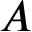Convert formula to latex. <formula><loc_0><loc_0><loc_500><loc_500>A</formula> 